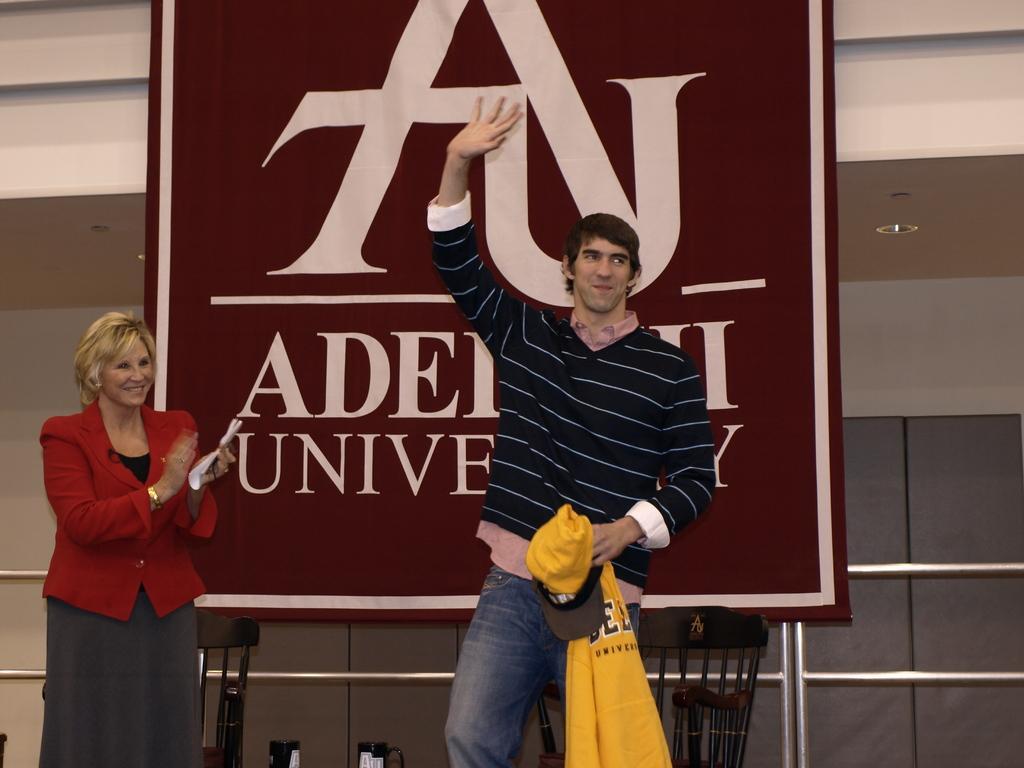Describe this image in one or two sentences. In the image we can see there are people standing and a woman is holding papers in her hand. There is a man holding cap and shirt in his hand. Behind there is a banner. 